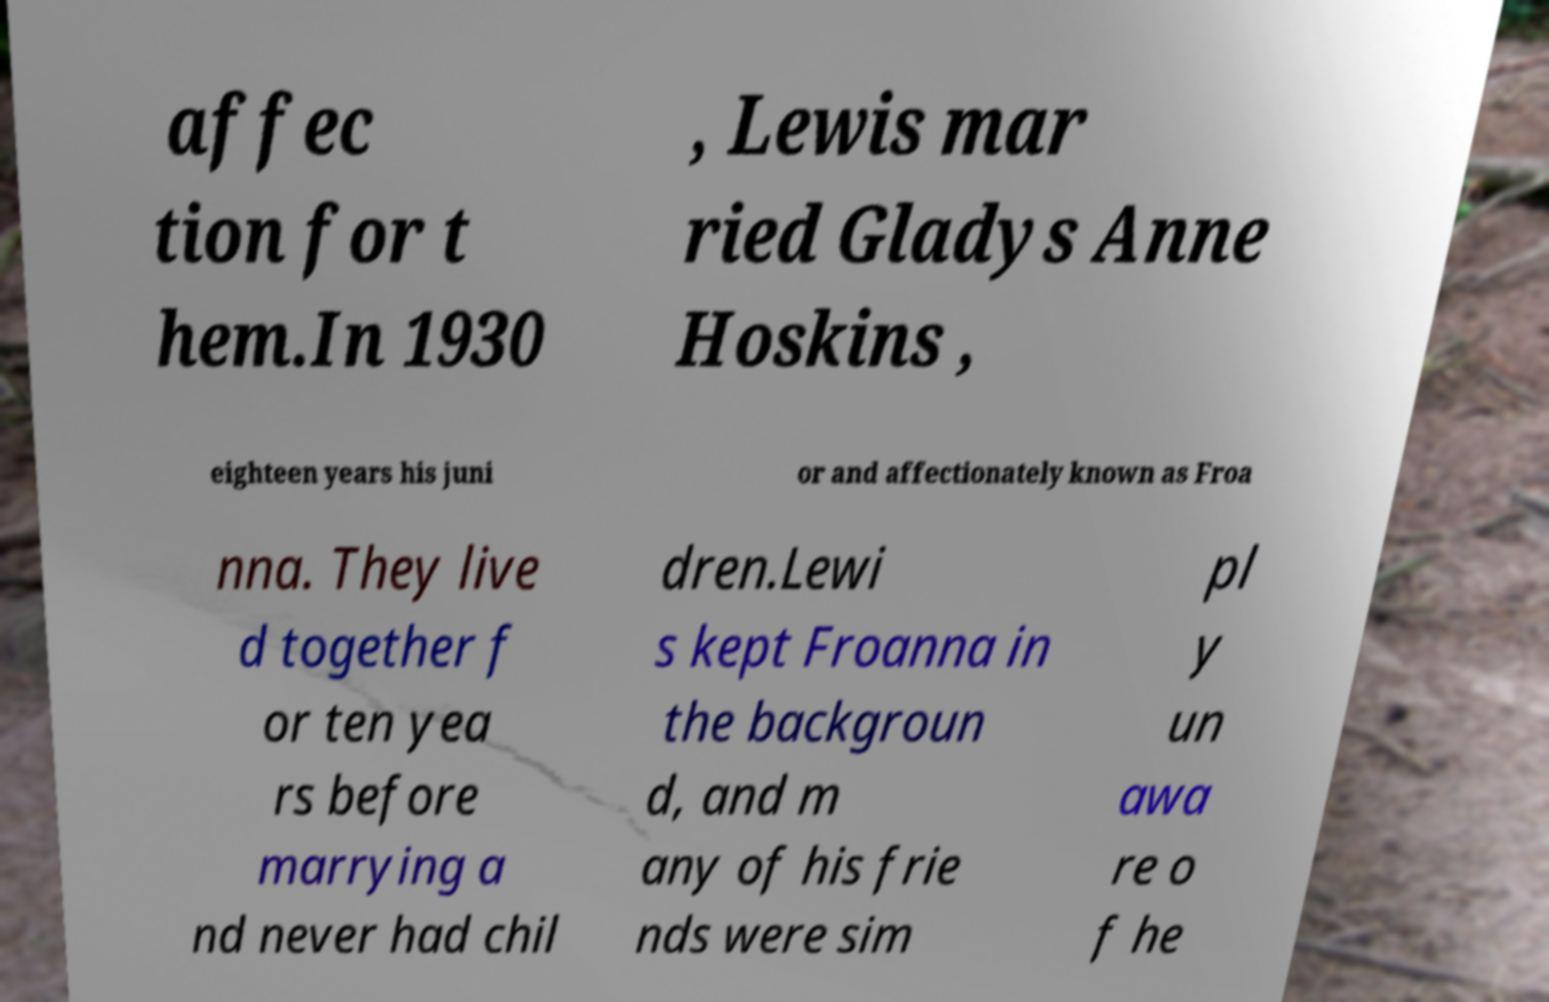There's text embedded in this image that I need extracted. Can you transcribe it verbatim? affec tion for t hem.In 1930 , Lewis mar ried Gladys Anne Hoskins , eighteen years his juni or and affectionately known as Froa nna. They live d together f or ten yea rs before marrying a nd never had chil dren.Lewi s kept Froanna in the backgroun d, and m any of his frie nds were sim pl y un awa re o f he 